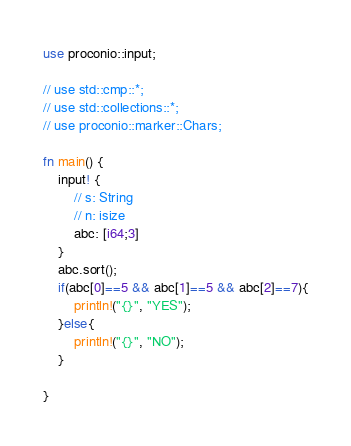<code> <loc_0><loc_0><loc_500><loc_500><_Rust_>use proconio::input;

// use std::cmp::*;
// use std::collections::*;
// use proconio::marker::Chars;

fn main() {
    input! {
        // s: String
        // n: isize
        abc: [i64;3]
    }
    abc.sort();
    if(abc[0]==5 && abc[1]==5 && abc[2]==7){
        println!("{}", "YES");
    }else{
        println!("{}", "NO");
    }
    
}
</code> 